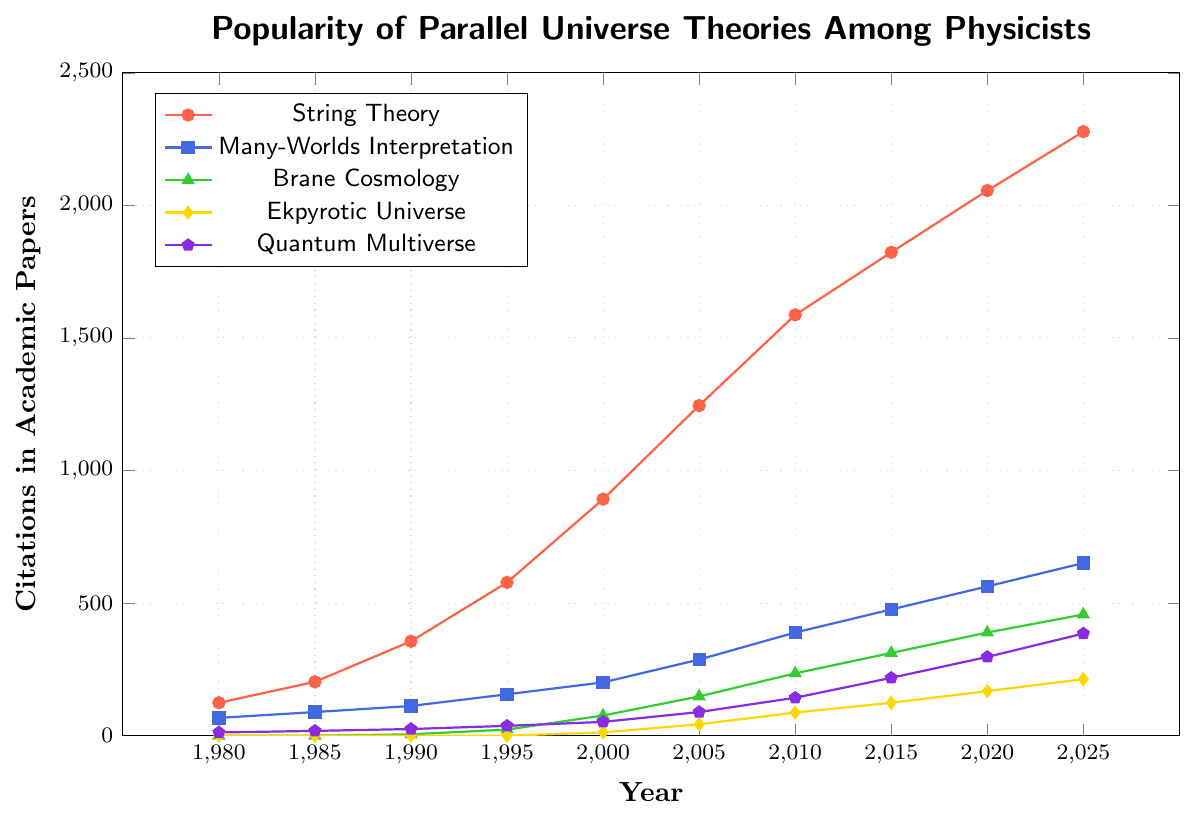What theory had the highest number of citations in 2020? The highest point on the vertical axis for the year 2020 corresponds to the String Theory line, which sits around 2056 citations.
Answer: String Theory How many citations did Quantum Multiverse receive in the year 1995? Locate 1995 on the horizontal axis and follow it up vertically until it meets the Quantum Multiverse pentagon-shaped marks. The number next to this position is 37.
Answer: 37 Which theory experienced the most significant growth between 2000 and 2005? Calculate the growth for each theory by subtracting the citation count in 2000 from that in 2005. String Theory: 1245 - 892 = 353, Many-Worlds Interpretation: 287 - 201 = 86, Brane Cosmology: 148 - 76 = 72, Ekpyrotic Universe: 43 - 12 = 31, Quantum Multiverse: 89 - 52 = 37. String Theory had the highest growth of 353.
Answer: String Theory Compare the citation counts of Ekpyrotic Universe and Brane Cosmology in the year 2015. Which one had more citations and by how much? For 2015, Ekpyrotic Universe had 124 citations and Brane Cosmology had 312 citations. The difference is 312 - 124 = 188. Brane Cosmology had more by 188.
Answer: Brane Cosmology, 188 From 1980 to 2010, what was the average number of citations for the Many-Worlds Interpretation? Sum the citations from 1980 to 2010 for Many-Worlds Interpretation: 67 + 89 + 112 + 156 + 201 + 287 + 389 = 1301. Divide by the number of years (7): 1301 / 7 ≈ 186 citations.
Answer: ~186 Which theory first surpassed 1000 citations and in what year? By following the lines and checking the citation counts, String Theory surpassed 1000 citations first, in the year 2005.
Answer: String Theory, 2005 What is the total number of citations for String Theory and Many-Worlds Interpretation in the year 2025? The citations for String Theory and Many-Worlds Interpretation in 2025 are 2278 and 651, respectively. The total is 2278 + 651 = 2929.
Answer: 2929 Between which consecutive years did Brane Cosmology see the highest increase in citations? Calculate the differences in citations for each interval: 1990-1995: 23 - 5 = 18, 1995-2000: 76 - 23 = 53, 2000-2005: 148 - 76 = 72, 2005-2010: 235 - 148 = 87, 2010-2015: 312 - 235 = 77, 2015-2020: 389 - 312 = 77, 2020-2025: 457 - 389 = 68. The highest increase happened between 2005 and 2010 with 87.
Answer: 2005 and 2010 